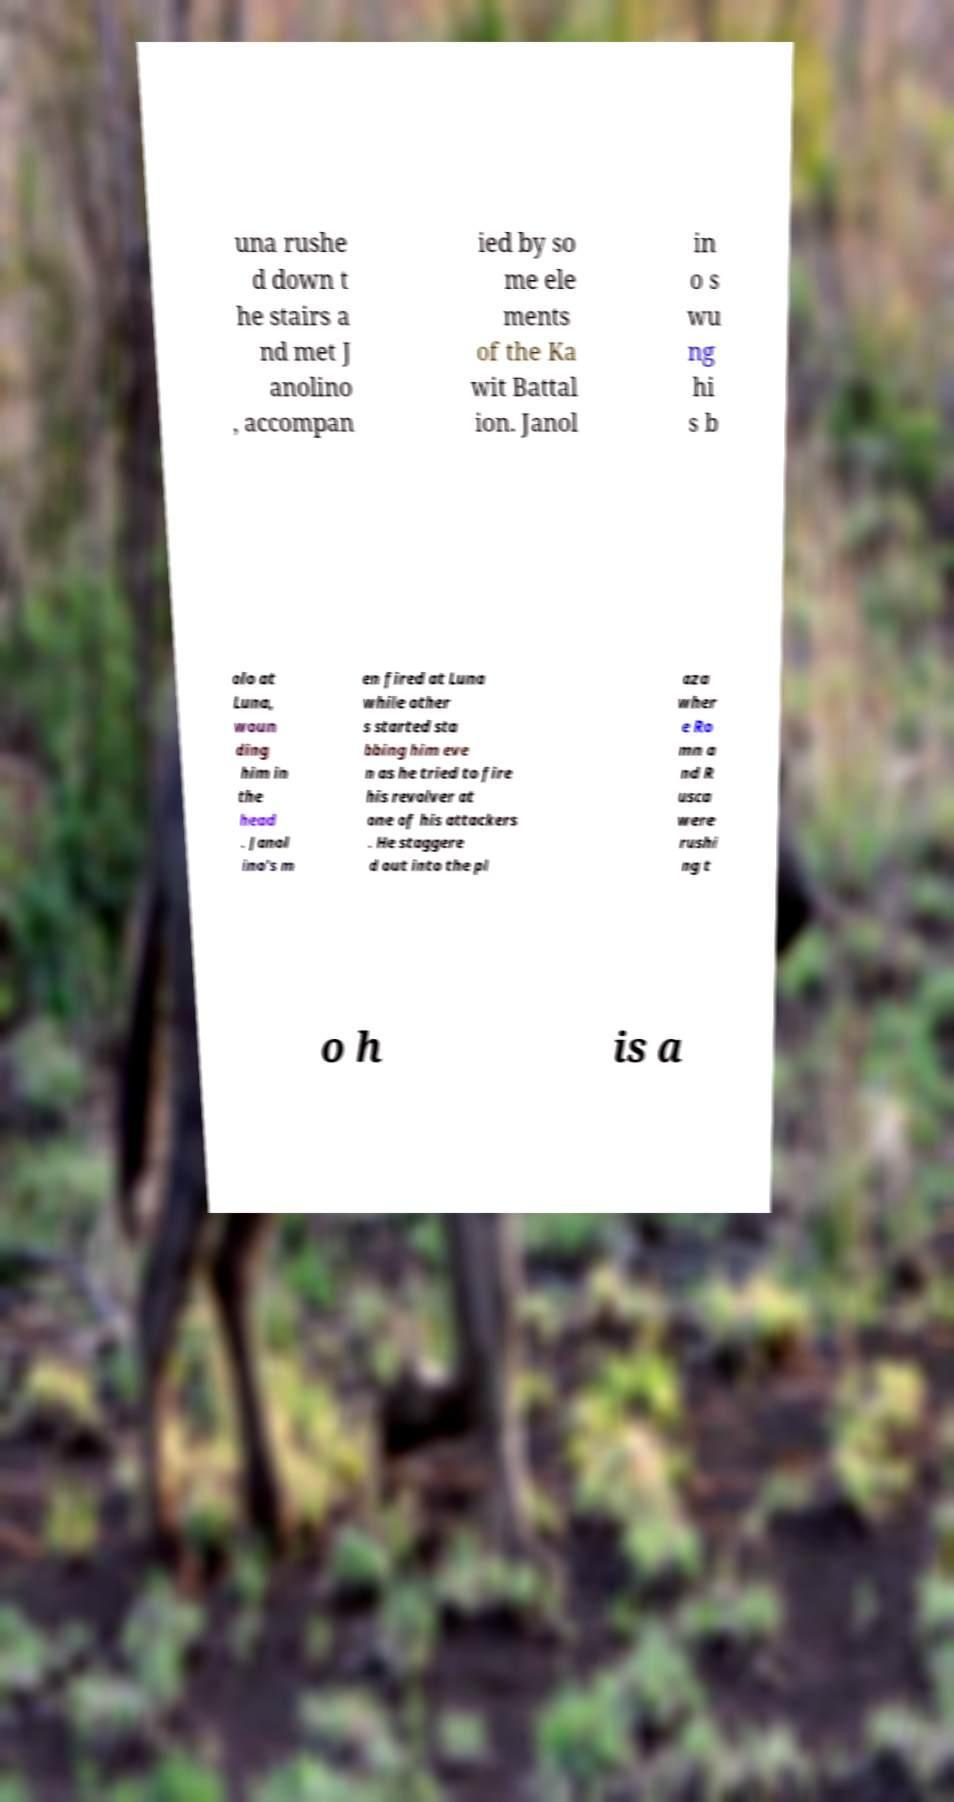Could you extract and type out the text from this image? una rushe d down t he stairs a nd met J anolino , accompan ied by so me ele ments of the Ka wit Battal ion. Janol in o s wu ng hi s b olo at Luna, woun ding him in the head . Janol ino's m en fired at Luna while other s started sta bbing him eve n as he tried to fire his revolver at one of his attackers . He staggere d out into the pl aza wher e Ro mn a nd R usca were rushi ng t o h is a 